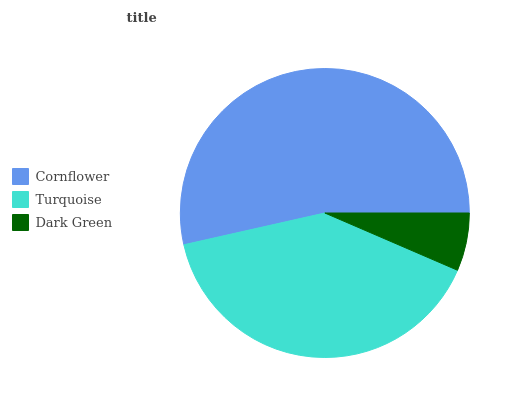Is Dark Green the minimum?
Answer yes or no. Yes. Is Cornflower the maximum?
Answer yes or no. Yes. Is Turquoise the minimum?
Answer yes or no. No. Is Turquoise the maximum?
Answer yes or no. No. Is Cornflower greater than Turquoise?
Answer yes or no. Yes. Is Turquoise less than Cornflower?
Answer yes or no. Yes. Is Turquoise greater than Cornflower?
Answer yes or no. No. Is Cornflower less than Turquoise?
Answer yes or no. No. Is Turquoise the high median?
Answer yes or no. Yes. Is Turquoise the low median?
Answer yes or no. Yes. Is Dark Green the high median?
Answer yes or no. No. Is Dark Green the low median?
Answer yes or no. No. 